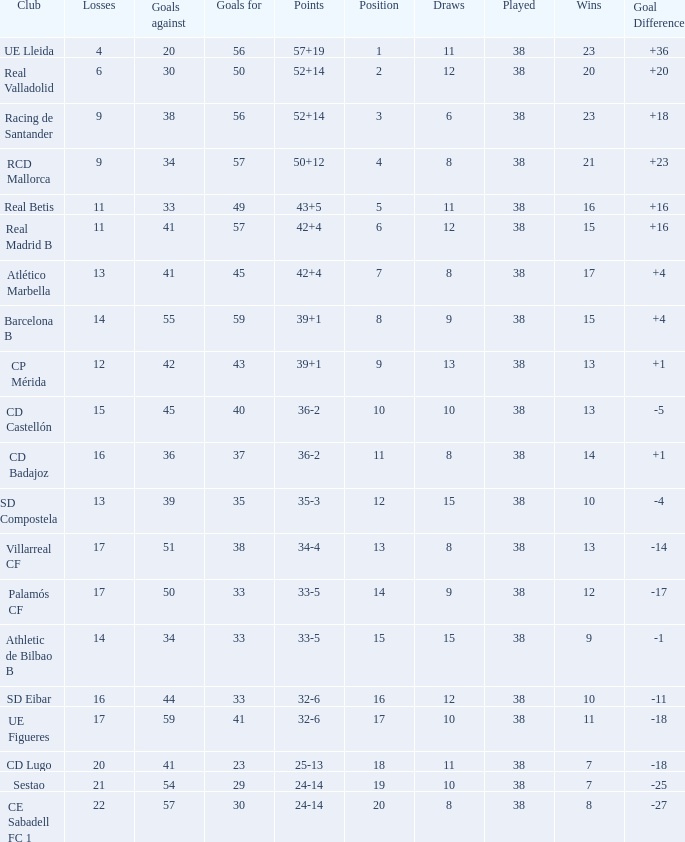What is the lowest position with 32-6 points and less then 59 goals when there are more than 38 played? None. 